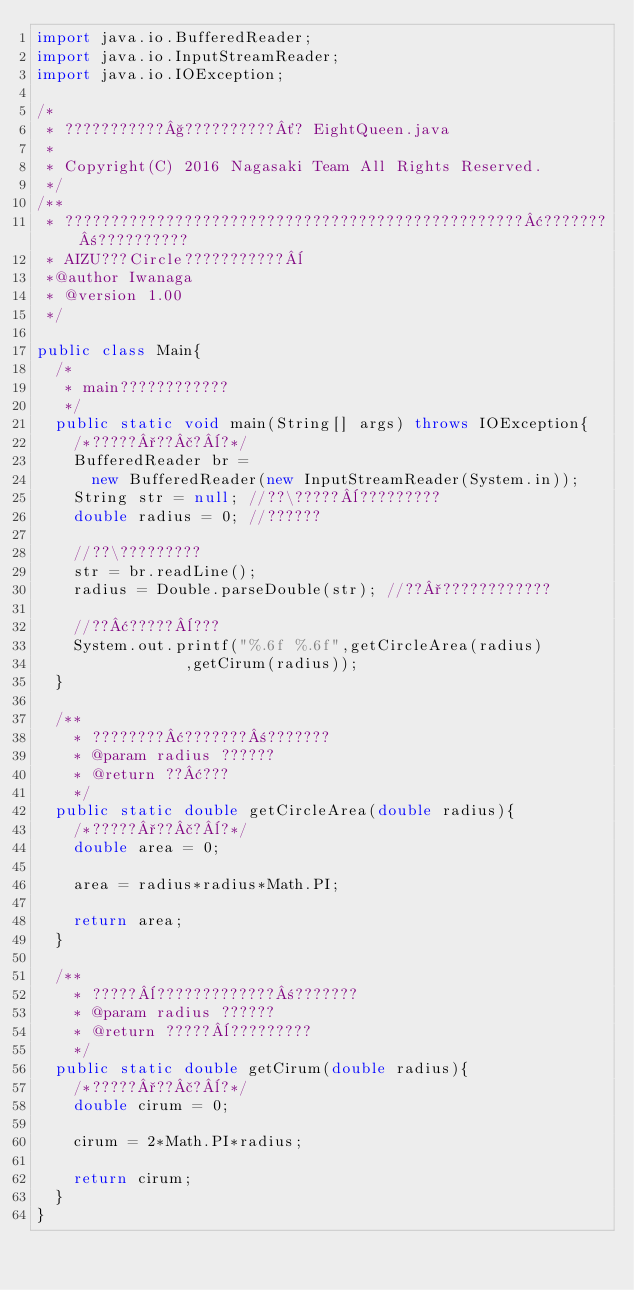Convert code to text. <code><loc_0><loc_0><loc_500><loc_500><_Java_>import java.io.BufferedReader;
import java.io.InputStreamReader;
import java.io.IOException;

/*
 * ???????????§??????????´? EightQueen.java
 *
 * Copyright(C) 2016 Nagasaki Team All Rights Reserved.
 */
/**
 * ??????????????????????????????????????????????????¢???????±??????????
 * AIZU???Circle???????????¨
 *@author Iwanaga
 * @version 1.00
 */

public class Main{
	/*
	 * main????????????
	 */
	public static void main(String[] args) throws IOException{
		/*?????°??£?¨?*/
		BufferedReader br =
			new BufferedReader(new InputStreamReader(System.in));
		String str = null; //??\?????¨?????????
		double radius = 0; //??????

		//??\?????????
		str = br.readLine();
		radius = Double.parseDouble(str); //??°????????????

		//??¢?????¨???
		System.out.printf("%.6f %.6f",getCircleArea(radius)
								,getCirum(radius));
	}

	/**
	  * ????????¢???????±???????
	  * @param radius ??????
	  * @return ??¢???
	  */
	public static double getCircleArea(double radius){
		/*?????°??£?¨?*/
		double area = 0;

		area = radius*radius*Math.PI;

		return area;
	}
	
	/**
	  * ?????¨?????????????±???????
	  * @param radius ??????
	  * @return ?????¨?????????
	  */
	public static double getCirum(double radius){
		/*?????°??£?¨?*/
		double cirum = 0;
		
		cirum = 2*Math.PI*radius;
		
		return cirum;
	}
}
		</code> 